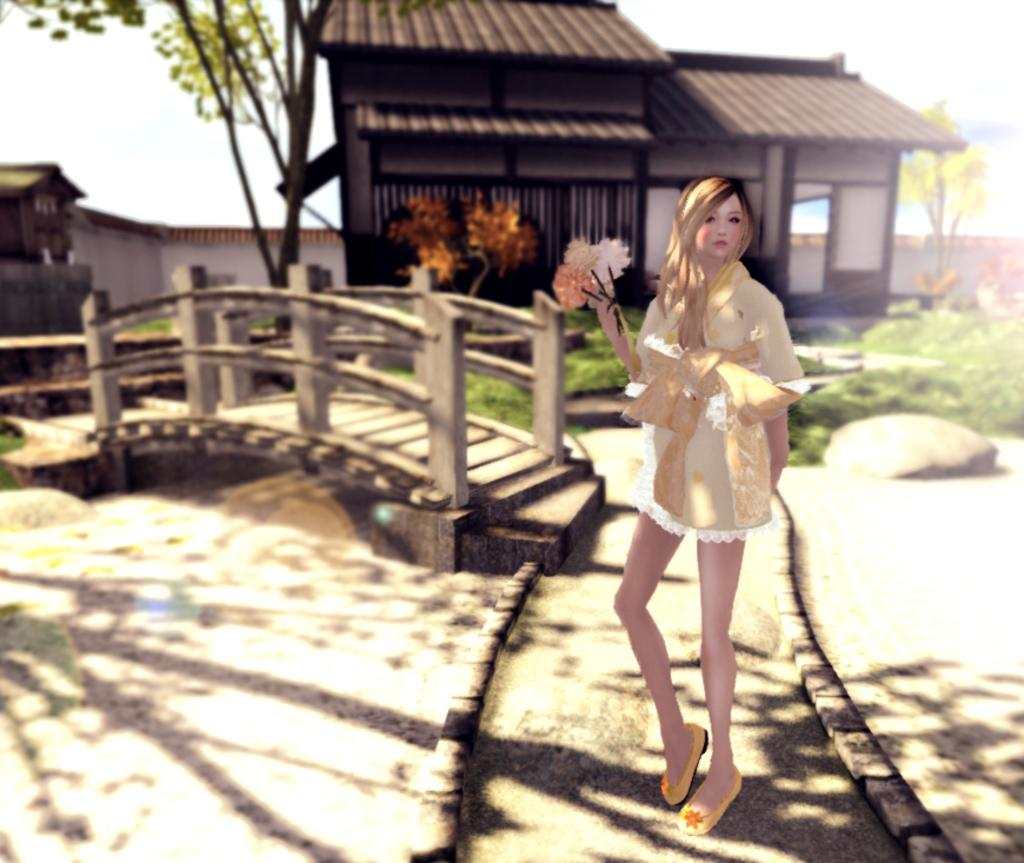What is the girl in the image doing? The girl is standing on a path in the image. What is the girl holding in her hand? The girl is holding flowers in her hand. What type of structures can be seen in the image? There are houses in the image. What type of vegetation is present in the image? There are trees in the image. What type of barrier is visible in the image? There is a wall in the image. What type of ground surface is visible in the image? There is grass in the image. What is visible in the background of the image? The sky is visible in the background of the image. What type of juice is the girl drinking in the image? There is no juice present in the image; the girl is holding flowers in her hand. 